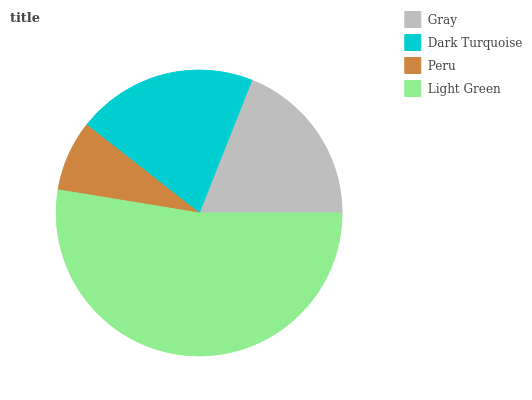Is Peru the minimum?
Answer yes or no. Yes. Is Light Green the maximum?
Answer yes or no. Yes. Is Dark Turquoise the minimum?
Answer yes or no. No. Is Dark Turquoise the maximum?
Answer yes or no. No. Is Dark Turquoise greater than Gray?
Answer yes or no. Yes. Is Gray less than Dark Turquoise?
Answer yes or no. Yes. Is Gray greater than Dark Turquoise?
Answer yes or no. No. Is Dark Turquoise less than Gray?
Answer yes or no. No. Is Dark Turquoise the high median?
Answer yes or no. Yes. Is Gray the low median?
Answer yes or no. Yes. Is Light Green the high median?
Answer yes or no. No. Is Peru the low median?
Answer yes or no. No. 